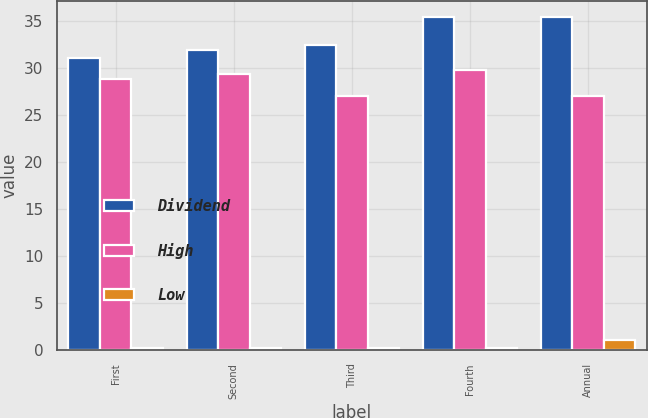Convert chart. <chart><loc_0><loc_0><loc_500><loc_500><stacked_bar_chart><ecel><fcel>First<fcel>Second<fcel>Third<fcel>Fourth<fcel>Annual<nl><fcel>Dividend<fcel>31.01<fcel>31.89<fcel>32.49<fcel>35.38<fcel>35.38<nl><fcel>High<fcel>28.83<fcel>29.39<fcel>27<fcel>29.82<fcel>27<nl><fcel>Low<fcel>0.26<fcel>0.26<fcel>0.26<fcel>0.26<fcel>1.04<nl></chart> 